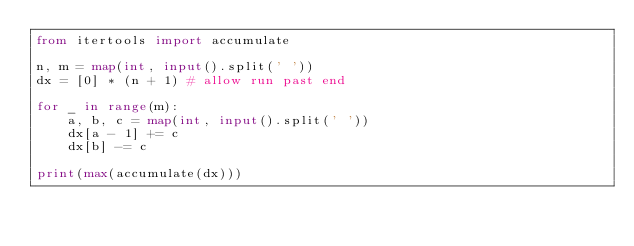Convert code to text. <code><loc_0><loc_0><loc_500><loc_500><_Python_>from itertools import accumulate

n, m = map(int, input().split(' '))
dx = [0] * (n + 1) # allow run past end

for _ in range(m):
    a, b, c = map(int, input().split(' '))
    dx[a - 1] += c
    dx[b] -= c

print(max(accumulate(dx)))
</code> 